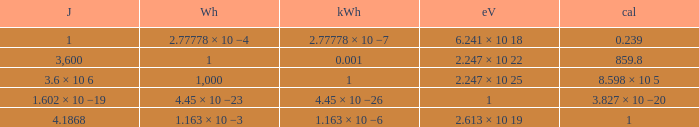How many electronvolts is 3,600 joules? 2.247 × 10 22. 